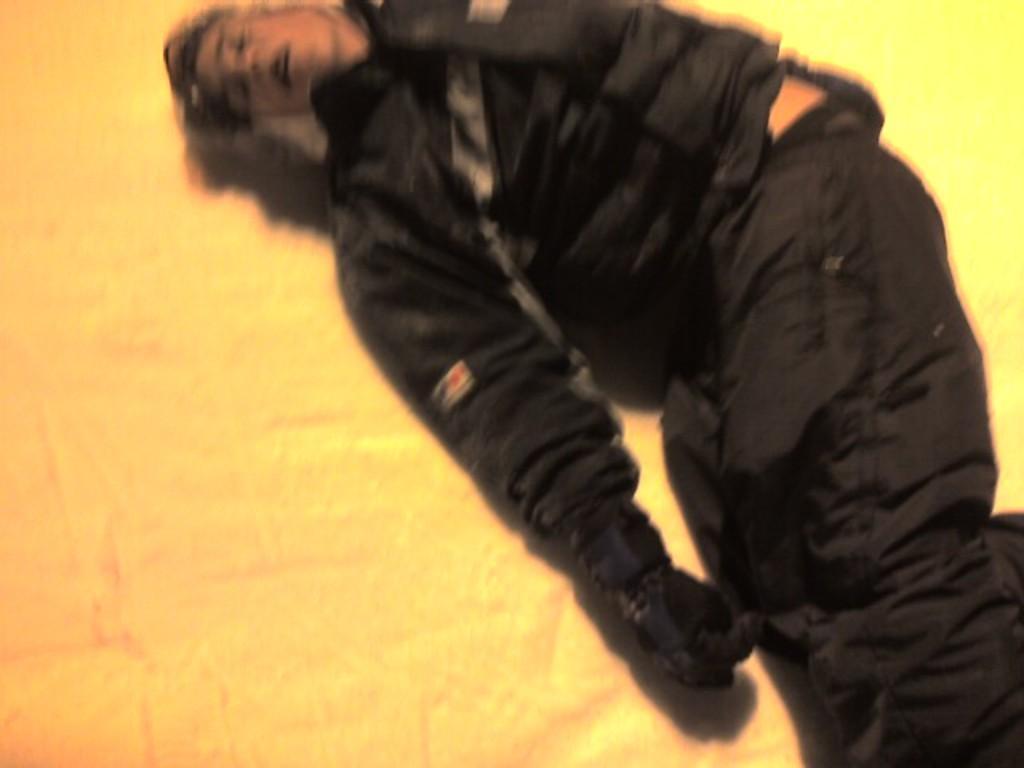Please provide a concise description of this image. In this image I can see a person is lying, this person is wearing black color coat and trouser. 